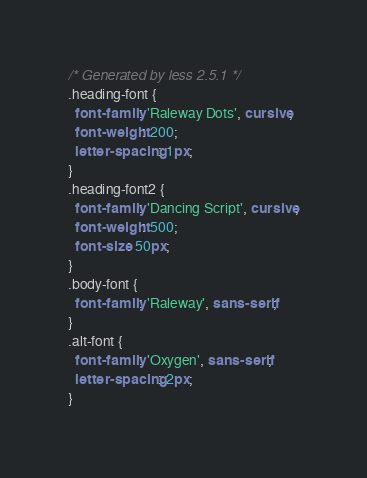<code> <loc_0><loc_0><loc_500><loc_500><_CSS_>/* Generated by less 2.5.1 */
.heading-font {
  font-family: 'Raleway Dots', cursive;
  font-weight: 200;
  letter-spacing: 1px;
}
.heading-font2 {
  font-family: 'Dancing Script', cursive;
  font-weight: 500;
  font-size: 50px;
}
.body-font {
  font-family: 'Raleway', sans-serif;
}
.alt-font {
  font-family: 'Oxygen', sans-serif;
  letter-spacing: 2px;
}
</code> 